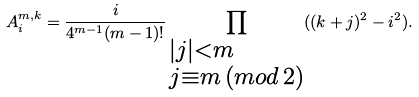<formula> <loc_0><loc_0><loc_500><loc_500>A ^ { m , k } _ { i } = \frac { i } { 4 ^ { m - 1 } ( m - 1 ) ! } \prod _ { \begin{subarray} { c } | j | < m \\ j \equiv m \, ( { m o d } \, 2 ) \end{subarray} } ( ( k + j ) ^ { 2 } - i ^ { 2 } ) .</formula> 